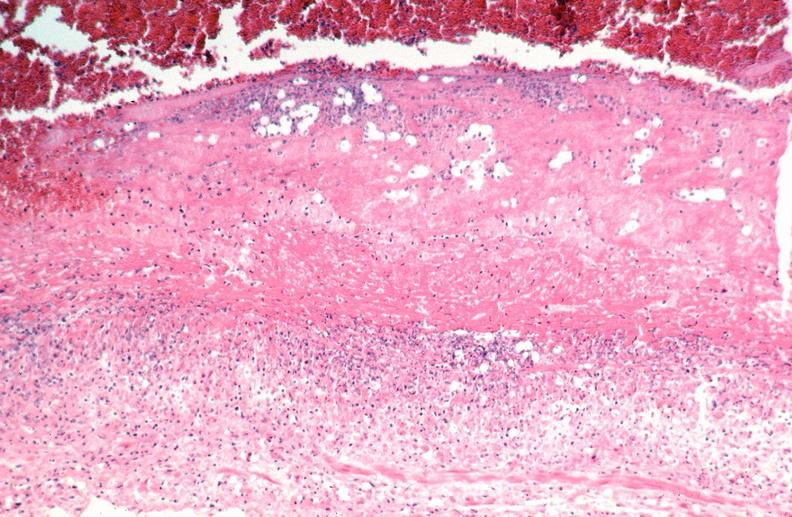s vasculature present?
Answer the question using a single word or phrase. Yes 